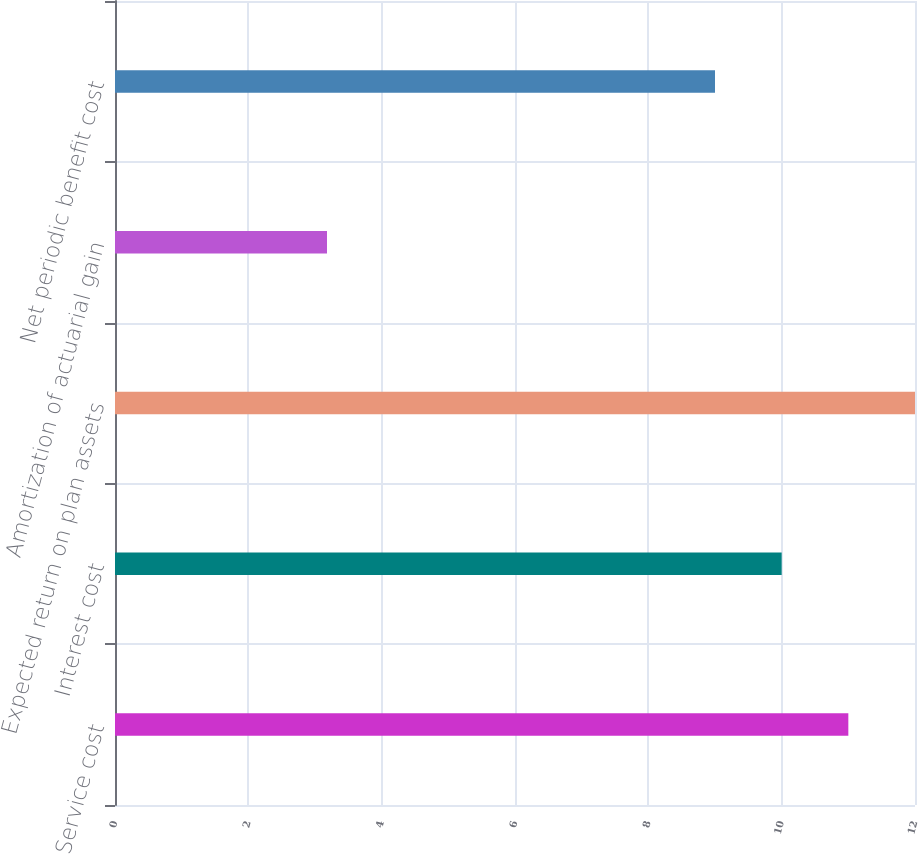<chart> <loc_0><loc_0><loc_500><loc_500><bar_chart><fcel>Service cost<fcel>Interest cost<fcel>Expected return on plan assets<fcel>Amortization of actuarial gain<fcel>Net periodic benefit cost<nl><fcel>11<fcel>10<fcel>12<fcel>3.18<fcel>9<nl></chart> 